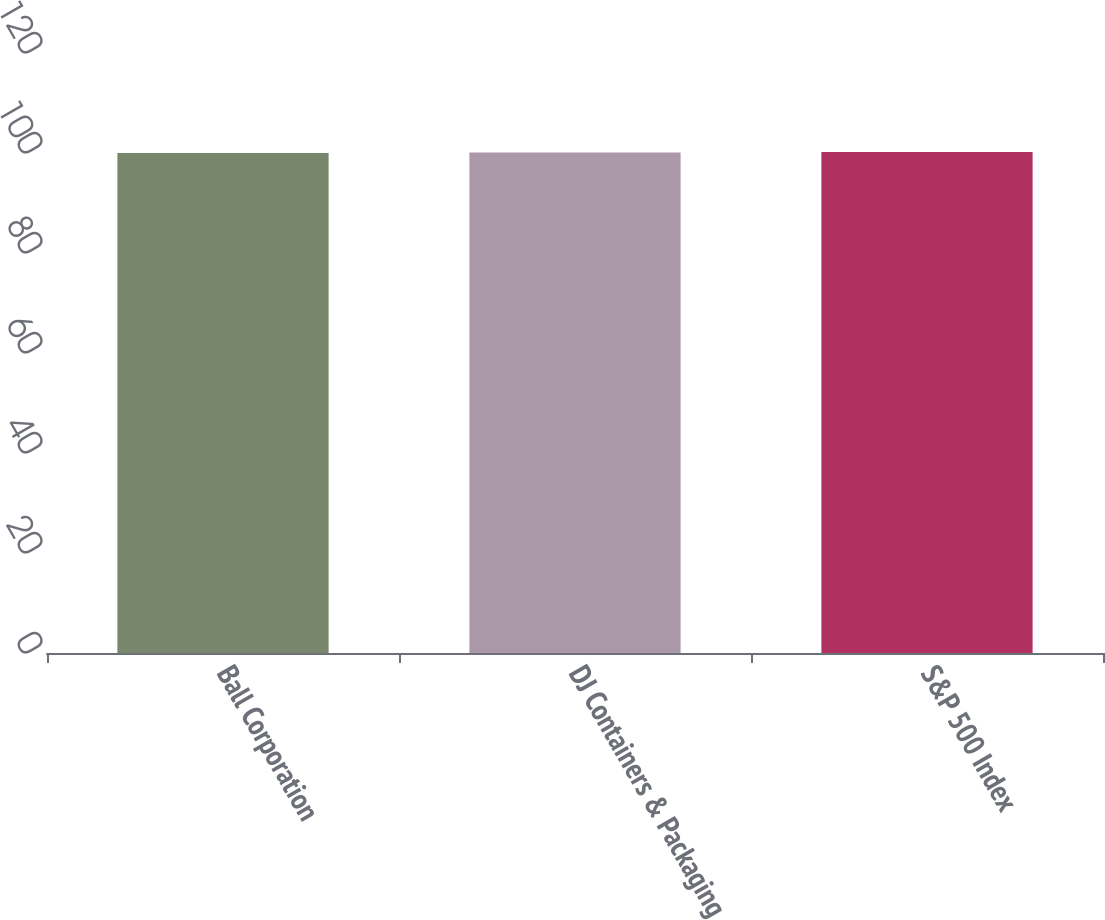<chart> <loc_0><loc_0><loc_500><loc_500><bar_chart><fcel>Ball Corporation<fcel>DJ Containers & Packaging<fcel>S&P 500 Index<nl><fcel>100<fcel>100.1<fcel>100.2<nl></chart> 